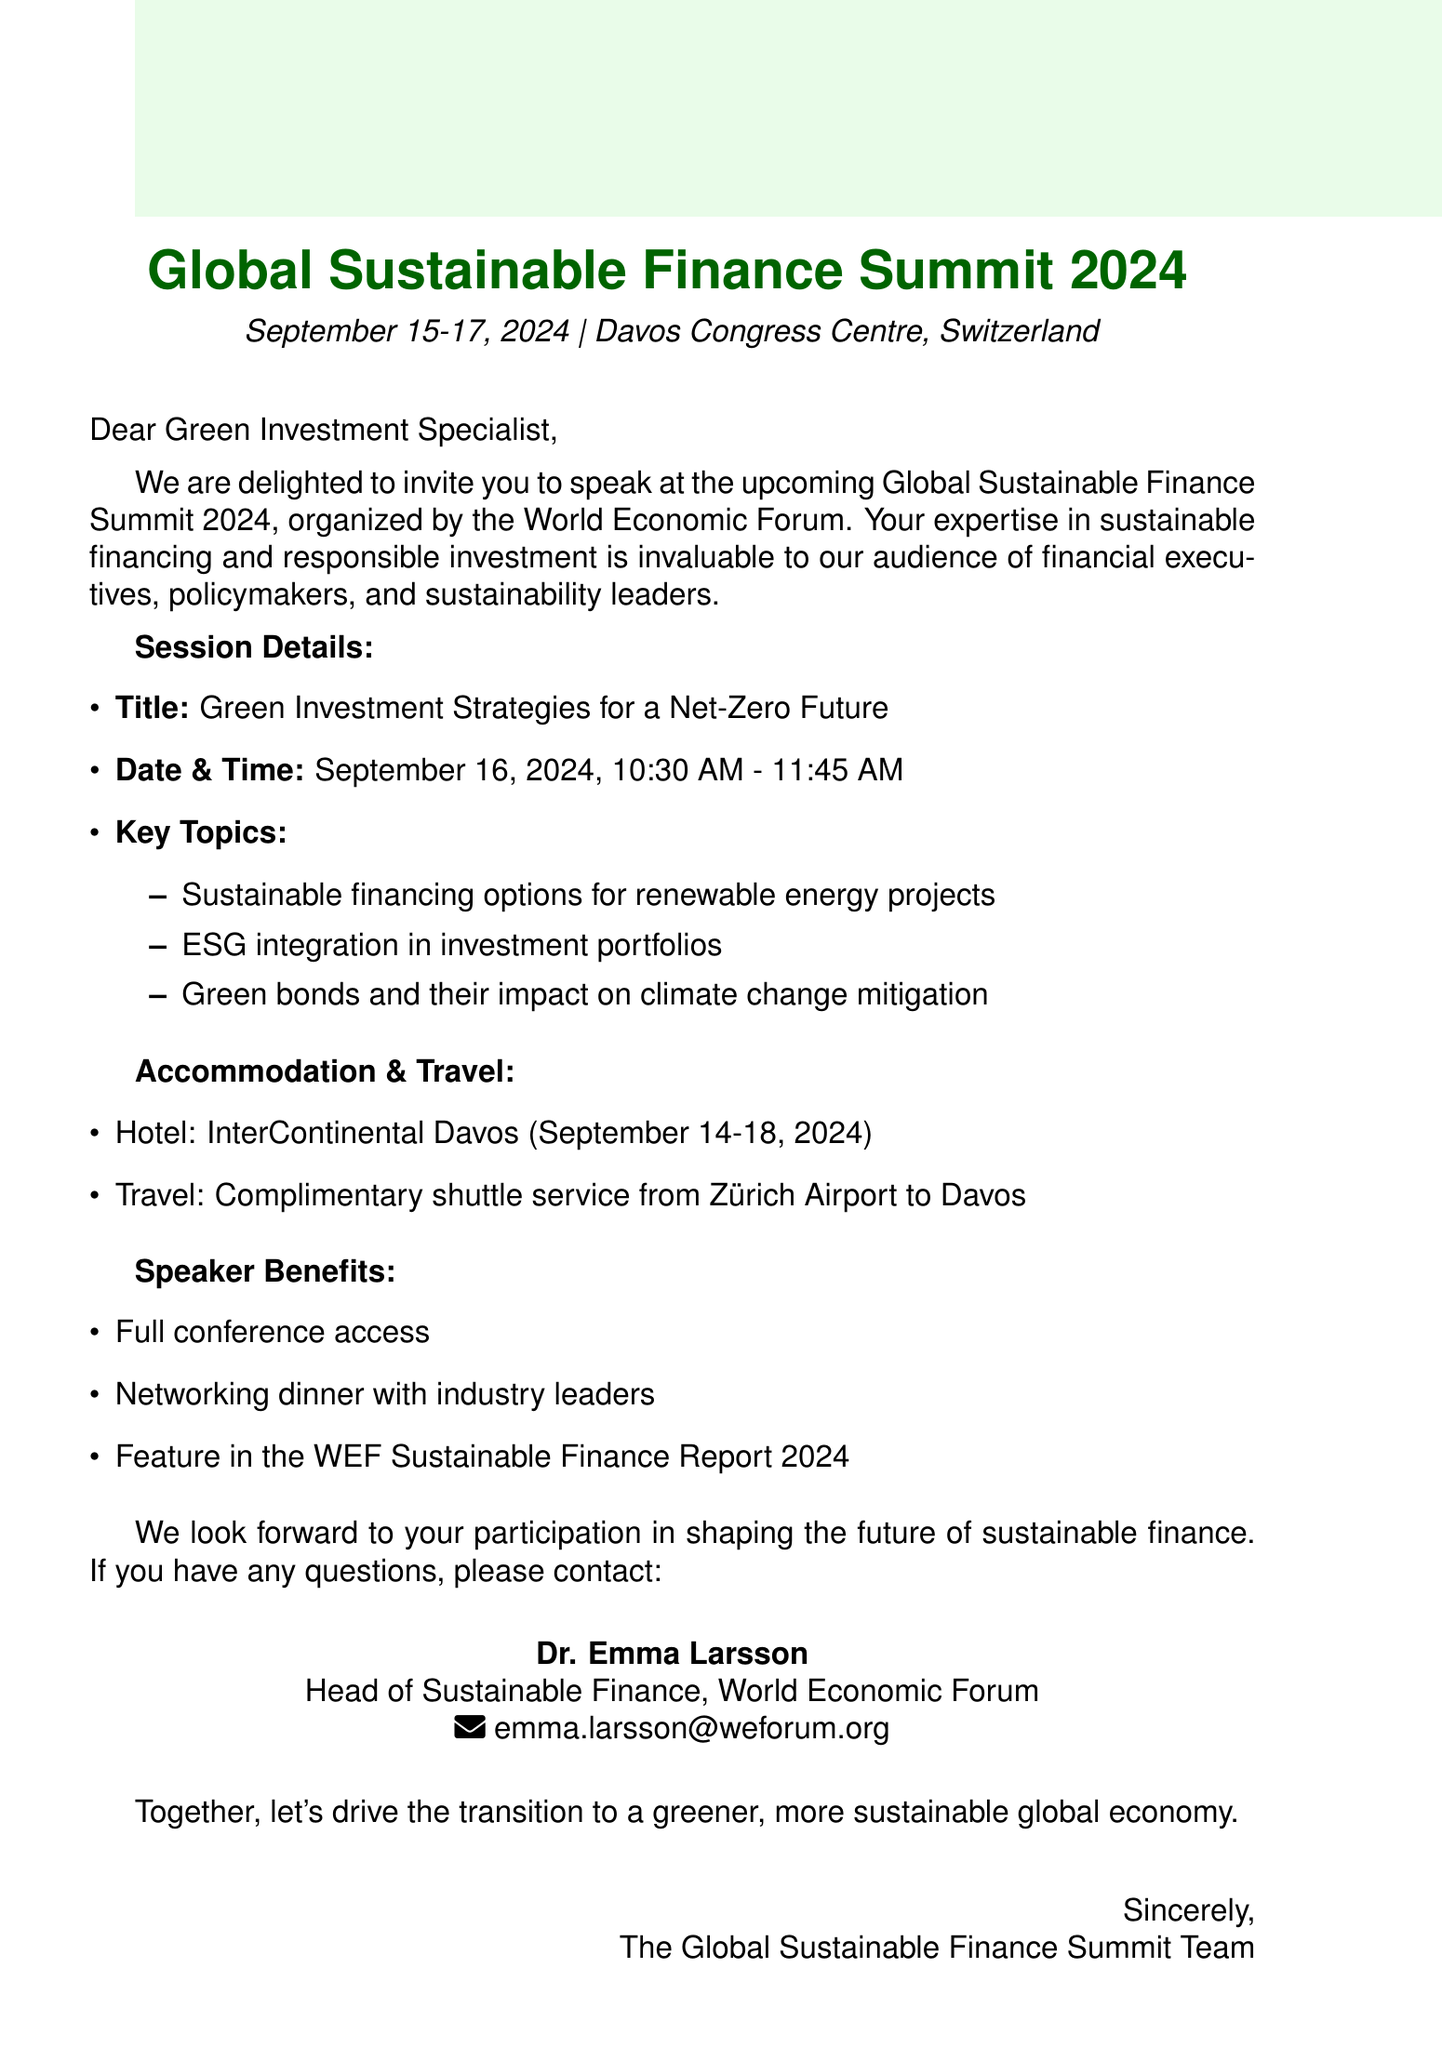What are the dates of the summit? The date of the summit is provided in the document as September 15-17, 2024.
Answer: September 15-17, 2024 Who is the organizer of the event? The document states that the organizer of the summit is the World Economic Forum.
Answer: World Economic Forum What is the title of the speaking session? The title of the speaking session is explicitly mentioned in the document as "Green Investment Strategies for a Net-Zero Future."
Answer: Green Investment Strategies for a Net-Zero Future What is the location of the conference? The document specifies the location of the summit as Davos Congress Centre, Davos, Switzerland.
Answer: Davos Congress Centre, Davos, Switzerland What time is the speaking slot scheduled for? The document clearly states that the speaking slot is scheduled for September 16, 2024, at 10:30 AM to 11:45 AM.
Answer: 10:30 AM - 11:45 AM What accommodation is arranged for the speakers? The hotel arranged for the speakers is mentioned as the InterContinental Davos.
Answer: InterContinental Davos What transportation service is provided for travel? The document mentions a complimentary shuttle service from Zürich Airport to Davos as part of the travel arrangements.
Answer: Complimentary shuttle service What are the benefits for speakers? The document lists several speaker benefits, including full conference access and a networking dinner, indicating various advantages for participants.
Answer: Full conference access Who should be contacted for questions regarding the event? The document provides Dr. Emma Larsson as the contact person for inquiries, along with her title and email.
Answer: Dr. Emma Larsson 